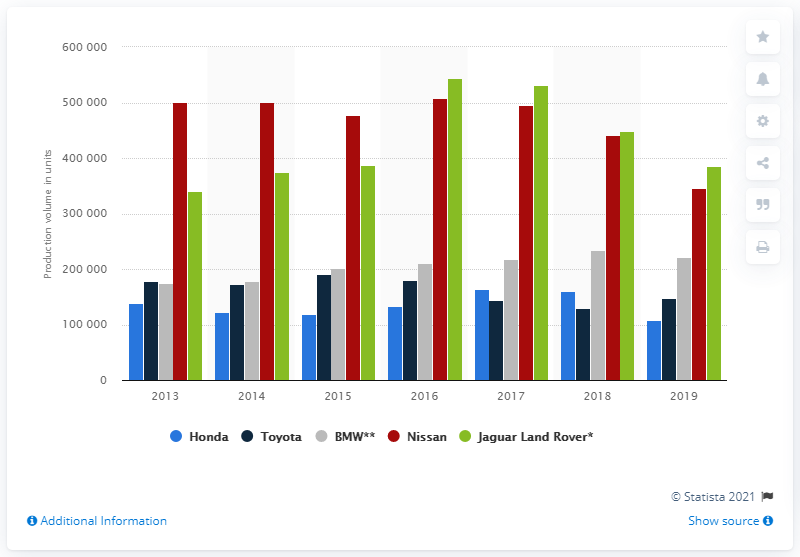Identify some key points in this picture. Toyota was the only brand that increased its output in 2019. Jaguar Land Rover was the leading automotive manufacturing brand in 2016. 